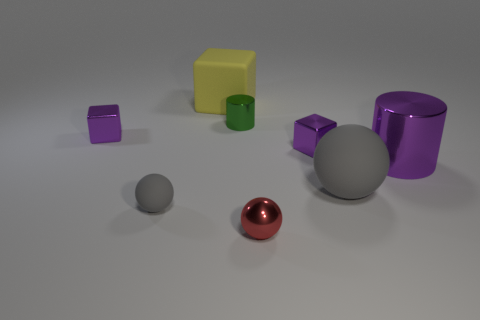Do the metallic block to the right of the big block and the metallic block to the left of the red sphere have the same color?
Give a very brief answer. Yes. There is a small thing that is the same color as the big sphere; what shape is it?
Make the answer very short. Sphere. How many objects are either tiny balls on the left side of the red sphere or tiny things?
Keep it short and to the point. 5. Does the yellow matte object have the same size as the purple cylinder?
Offer a very short reply. Yes. There is a cylinder that is on the left side of the large matte ball; what color is it?
Your answer should be very brief. Green. What size is the yellow cube that is the same material as the small gray thing?
Make the answer very short. Large. Is the size of the green metallic cylinder the same as the shiny thing that is in front of the large purple thing?
Ensure brevity in your answer.  Yes. What material is the gray thing that is on the left side of the large matte cube?
Your answer should be very brief. Rubber. There is a tiny purple metal thing that is to the left of the green metallic object; how many matte spheres are in front of it?
Your answer should be very brief. 2. Are there any large cyan matte things that have the same shape as the green metallic thing?
Provide a short and direct response. No. 